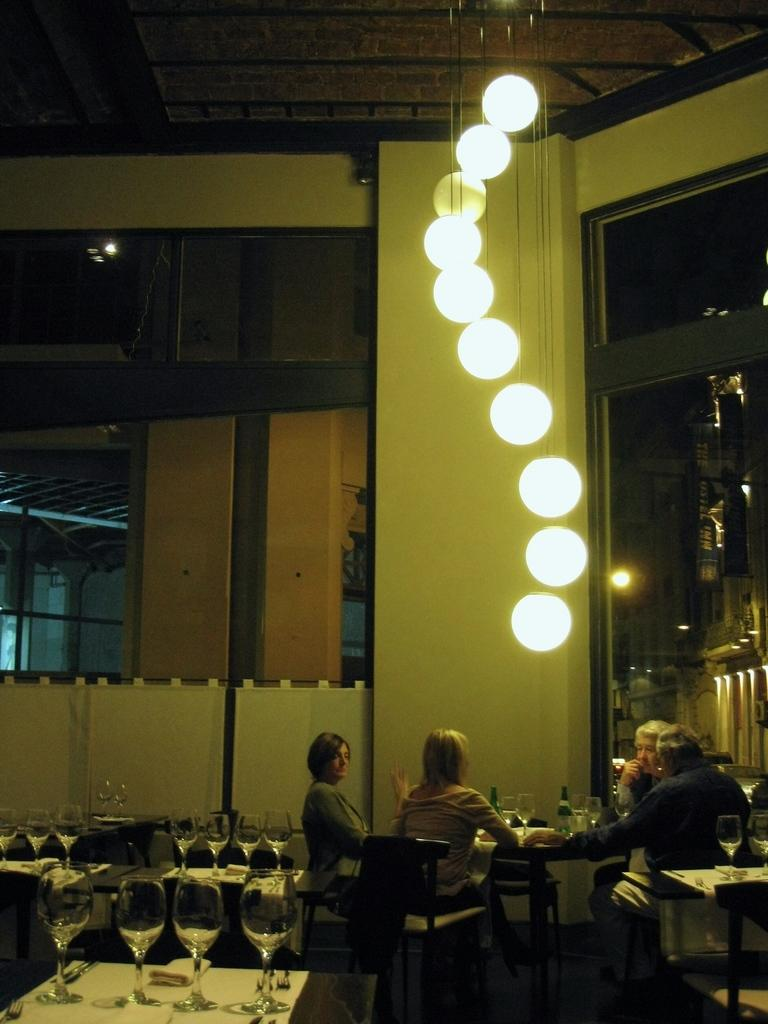How many people are sitting in the image? There are four persons sitting on chairs in the image. What objects are on the tables? There are glasses and bottles on the tables. What type of lighting is visible in the image? There are lights visible on the top. What can be seen in the background of the image? There is a wall and a glass window in the background. How many fish can be seen swimming in the image? There are no fish present in the image. What type of camera is being used to capture the image? The image does not show any camera being used; it is a still image. 